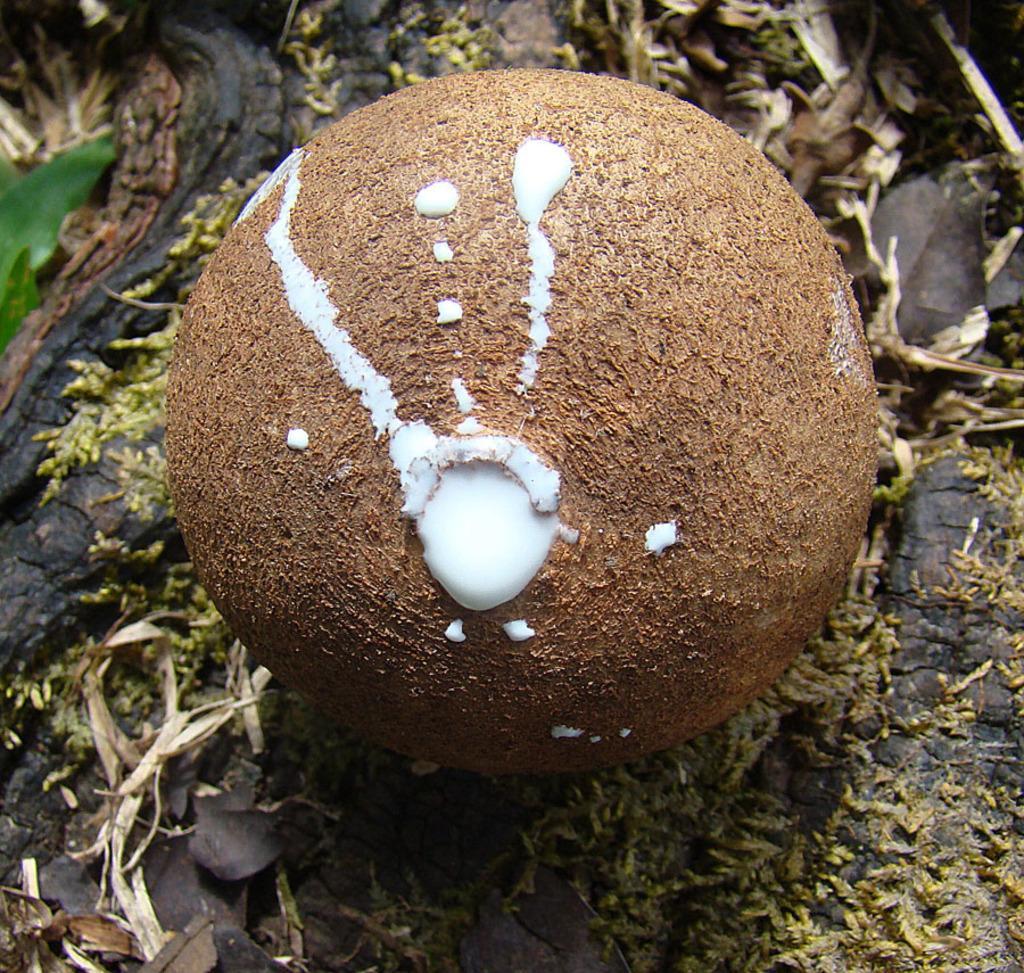Can you describe this image briefly? In this image we can see an object which looks like a fruit to the tree and there are some leaves around it. 